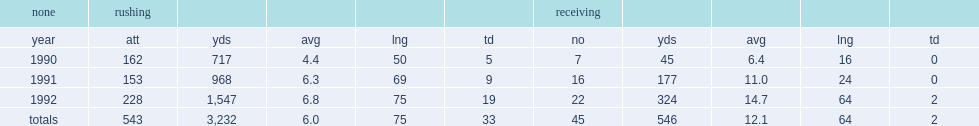How many rushing yards did garrison hearst finish with? 3232.0. 